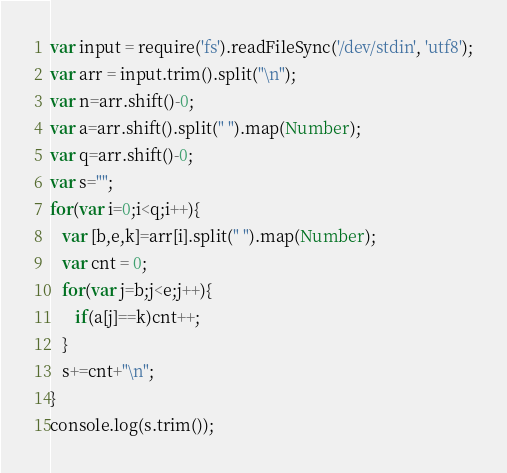Convert code to text. <code><loc_0><loc_0><loc_500><loc_500><_JavaScript_>var input = require('fs').readFileSync('/dev/stdin', 'utf8');
var arr = input.trim().split("\n");
var n=arr.shift()-0;
var a=arr.shift().split(" ").map(Number);
var q=arr.shift()-0;
var s="";
for(var i=0;i<q;i++){
   var [b,e,k]=arr[i].split(" ").map(Number);
   var cnt = 0;
   for(var j=b;j<e;j++){
      if(a[j]==k)cnt++;
   }
   s+=cnt+"\n";
}
console.log(s.trim());
</code> 